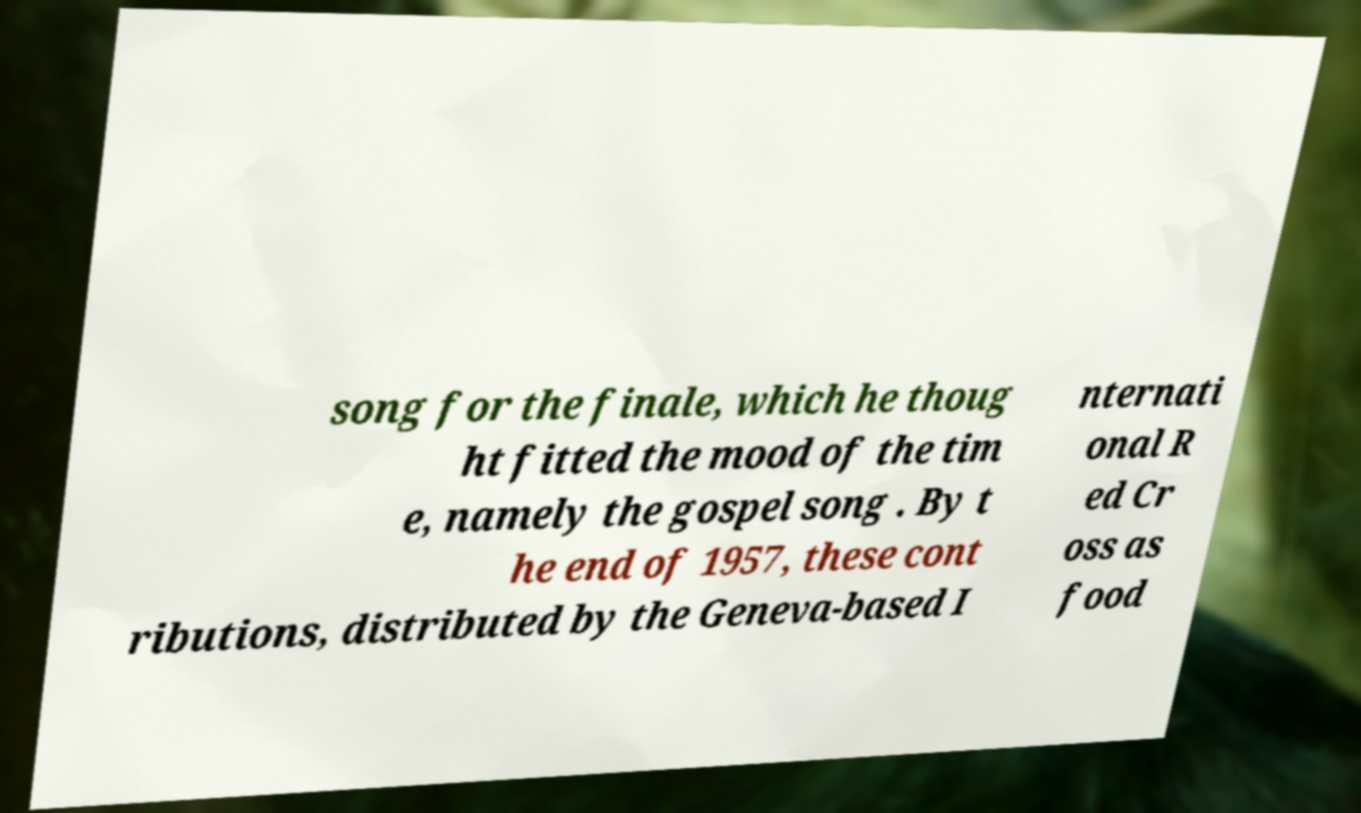Could you extract and type out the text from this image? song for the finale, which he thoug ht fitted the mood of the tim e, namely the gospel song . By t he end of 1957, these cont ributions, distributed by the Geneva-based I nternati onal R ed Cr oss as food 